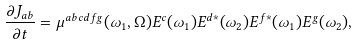Convert formula to latex. <formula><loc_0><loc_0><loc_500><loc_500>\frac { \partial J _ { a b } } { \partial t } = \mu ^ { a b c d f g } ( \omega _ { 1 } , \Omega ) E ^ { c } { ( } \omega _ { 1 } { ) } E ^ { d * } { ( } \omega _ { 2 } { ) } E ^ { f * } { ( } \omega _ { 1 } { ) } E ^ { g } { ( } \omega _ { 2 } { ) } ,</formula> 